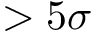Convert formula to latex. <formula><loc_0><loc_0><loc_500><loc_500>> 5 \sigma</formula> 